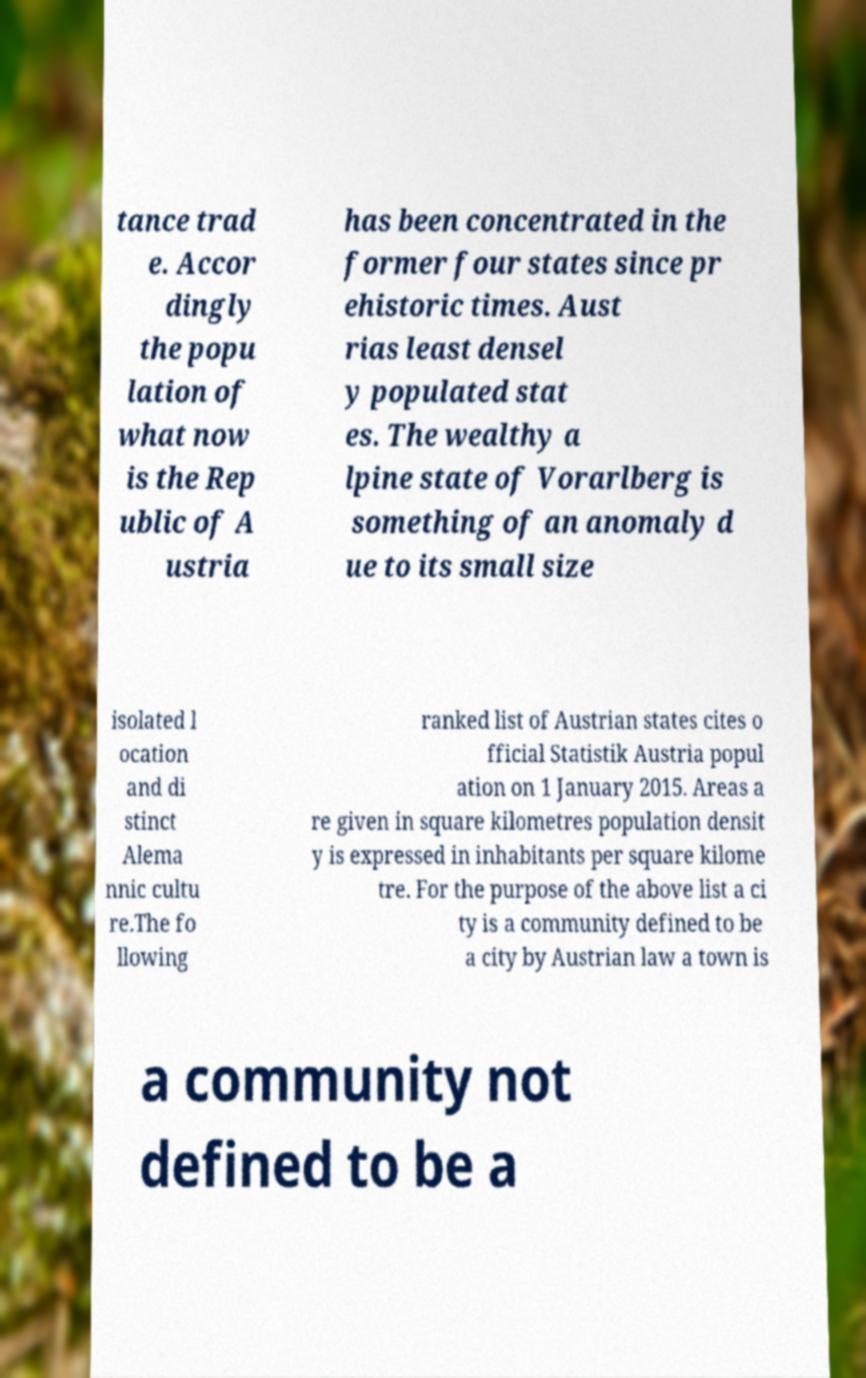Could you assist in decoding the text presented in this image and type it out clearly? tance trad e. Accor dingly the popu lation of what now is the Rep ublic of A ustria has been concentrated in the former four states since pr ehistoric times. Aust rias least densel y populated stat es. The wealthy a lpine state of Vorarlberg is something of an anomaly d ue to its small size isolated l ocation and di stinct Alema nnic cultu re.The fo llowing ranked list of Austrian states cites o fficial Statistik Austria popul ation on 1 January 2015. Areas a re given in square kilometres population densit y is expressed in inhabitants per square kilome tre. For the purpose of the above list a ci ty is a community defined to be a city by Austrian law a town is a community not defined to be a 